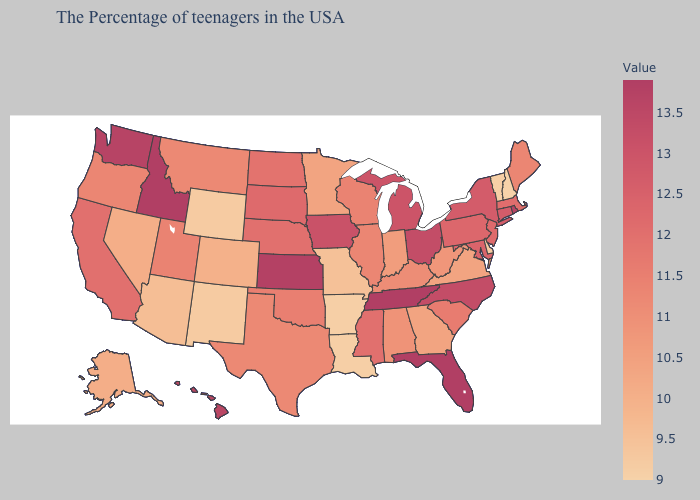Which states have the lowest value in the USA?
Keep it brief. New Hampshire. Does Maryland have the lowest value in the USA?
Quick response, please. No. Does Nevada have a higher value than Kentucky?
Give a very brief answer. No. Among the states that border North Carolina , does South Carolina have the highest value?
Be succinct. No. Does Rhode Island have the highest value in the Northeast?
Quick response, please. Yes. Which states have the lowest value in the South?
Keep it brief. Louisiana, Arkansas. 